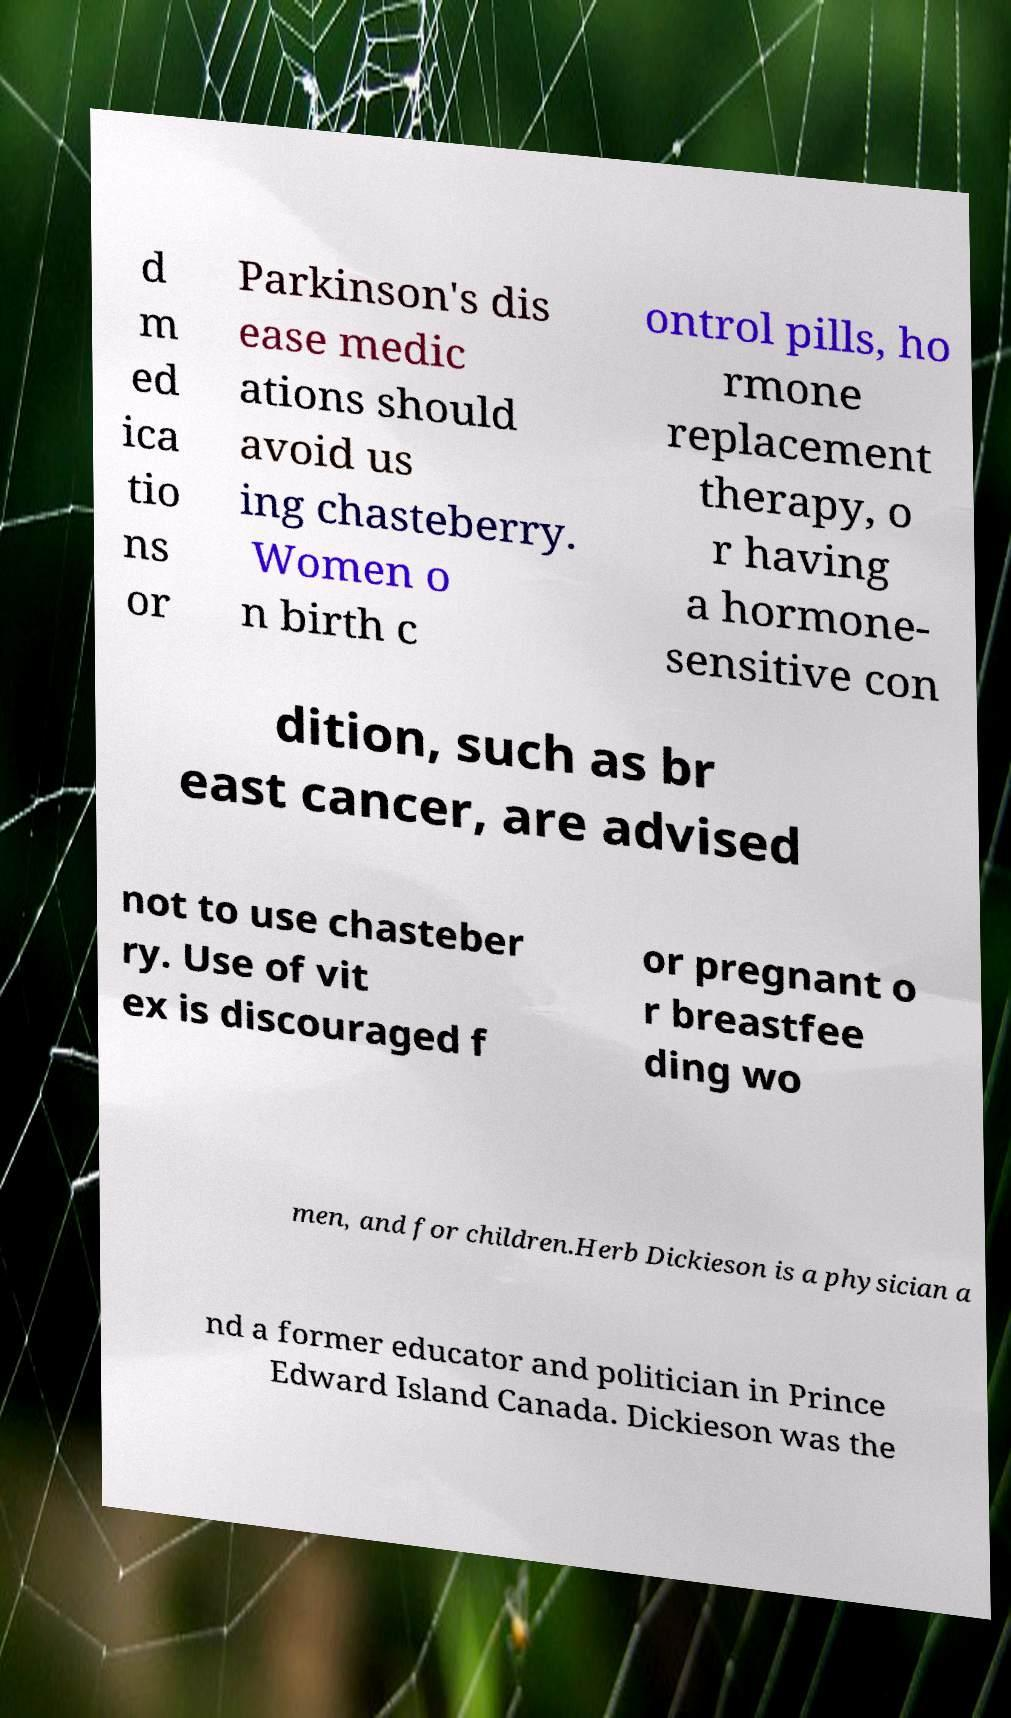I need the written content from this picture converted into text. Can you do that? d m ed ica tio ns or Parkinson's dis ease medic ations should avoid us ing chasteberry. Women o n birth c ontrol pills, ho rmone replacement therapy, o r having a hormone- sensitive con dition, such as br east cancer, are advised not to use chasteber ry. Use of vit ex is discouraged f or pregnant o r breastfee ding wo men, and for children.Herb Dickieson is a physician a nd a former educator and politician in Prince Edward Island Canada. Dickieson was the 